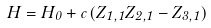<formula> <loc_0><loc_0><loc_500><loc_500>H = H _ { 0 } + c \, ( Z _ { 1 , 1 } Z _ { 2 , 1 } - Z _ { 3 , 1 } )</formula> 